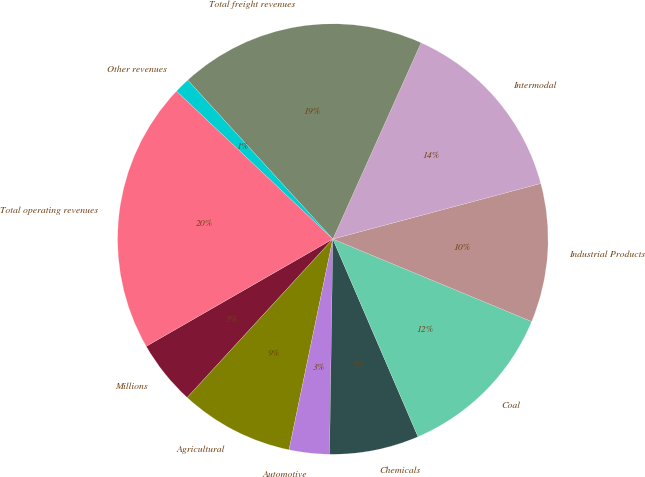<chart> <loc_0><loc_0><loc_500><loc_500><pie_chart><fcel>Millions<fcel>Agricultural<fcel>Automotive<fcel>Chemicals<fcel>Coal<fcel>Industrial Products<fcel>Intermodal<fcel>Total freight revenues<fcel>Other revenues<fcel>Total operating revenues<nl><fcel>4.87%<fcel>8.57%<fcel>3.02%<fcel>6.72%<fcel>12.27%<fcel>10.42%<fcel>14.12%<fcel>18.51%<fcel>1.17%<fcel>20.36%<nl></chart> 